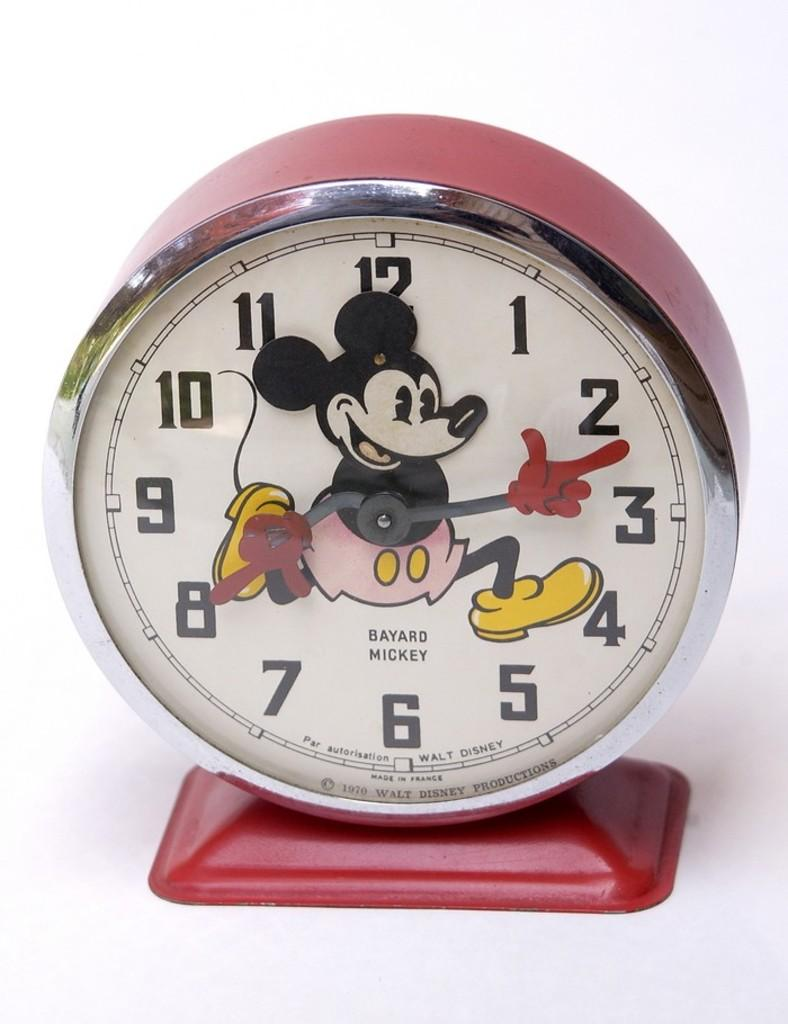<image>
Summarize the visual content of the image. A Mickey Mouse clock reads the time as 2:40. 